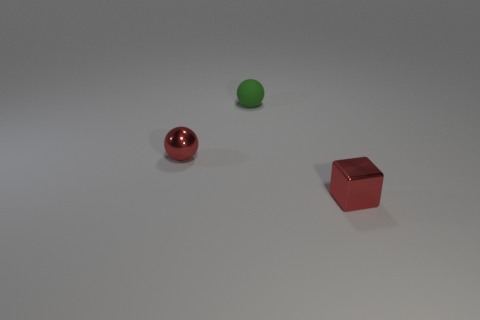Add 2 green rubber things. How many objects exist? 5 Subtract all blocks. How many objects are left? 2 Subtract all tiny balls. Subtract all tiny metallic cubes. How many objects are left? 0 Add 2 green things. How many green things are left? 3 Add 1 big purple cylinders. How many big purple cylinders exist? 1 Subtract 0 blue spheres. How many objects are left? 3 